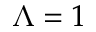Convert formula to latex. <formula><loc_0><loc_0><loc_500><loc_500>\Lambda = 1</formula> 